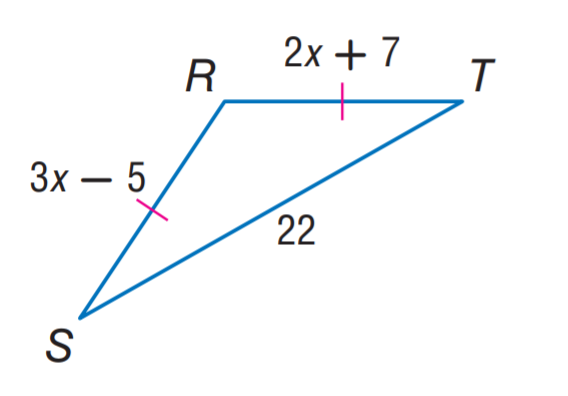Answer the mathemtical geometry problem and directly provide the correct option letter.
Question: Find x.
Choices: A: 7 B: 12 C: 22 D: 31 B 